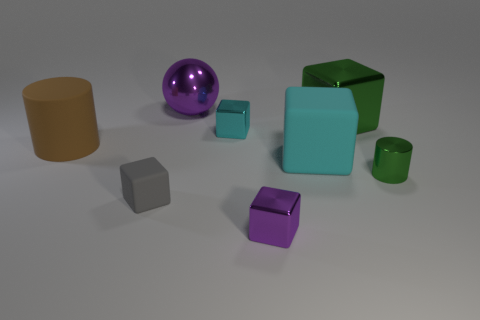How many green blocks have the same size as the purple sphere?
Provide a succinct answer. 1. Is the material of the large block that is behind the big cyan matte block the same as the cyan block that is on the left side of the large matte cube?
Your response must be concise. Yes. What material is the green thing that is behind the brown cylinder that is behind the tiny cylinder made of?
Provide a succinct answer. Metal. There is a cylinder that is to the right of the purple metallic ball; what material is it?
Your response must be concise. Metal. What number of small purple shiny objects are the same shape as the small gray matte thing?
Give a very brief answer. 1. Does the shiny cylinder have the same color as the big metal cube?
Provide a succinct answer. Yes. There is a cylinder that is behind the matte object to the right of the purple metallic thing that is behind the tiny green metal cylinder; what is it made of?
Provide a succinct answer. Rubber. Are there any big cubes in front of the green metallic block?
Keep it short and to the point. Yes. There is a purple shiny thing that is the same size as the brown thing; what shape is it?
Provide a succinct answer. Sphere. Does the large cyan object have the same material as the brown thing?
Provide a succinct answer. Yes. 